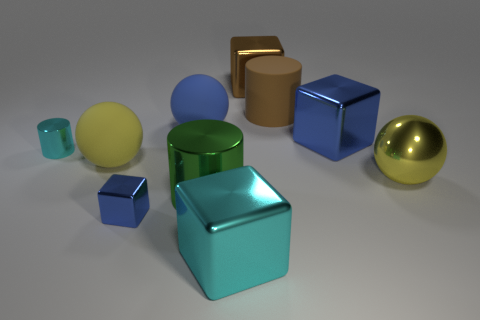Which of these objects appears to be the most reflective? The golden sphere seems to have the most reflective surface, as it mirrors the environment most clearly among all the present objects. 